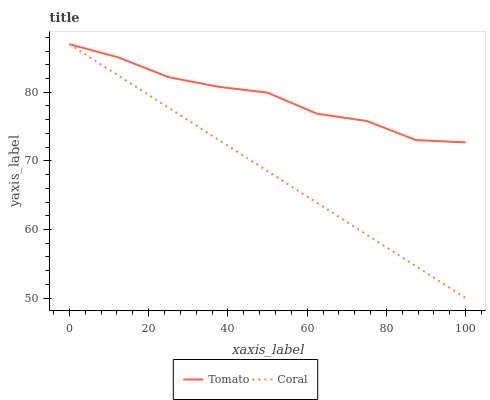Does Coral have the minimum area under the curve?
Answer yes or no. Yes. Does Tomato have the maximum area under the curve?
Answer yes or no. Yes. Does Coral have the maximum area under the curve?
Answer yes or no. No. Is Coral the smoothest?
Answer yes or no. Yes. Is Tomato the roughest?
Answer yes or no. Yes. Is Coral the roughest?
Answer yes or no. No. Does Coral have the highest value?
Answer yes or no. Yes. 